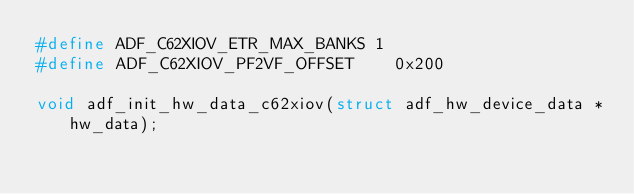<code> <loc_0><loc_0><loc_500><loc_500><_C_>#define ADF_C62XIOV_ETR_MAX_BANKS 1
#define ADF_C62XIOV_PF2VF_OFFSET	0x200

void adf_init_hw_data_c62xiov(struct adf_hw_device_data *hw_data);</code> 